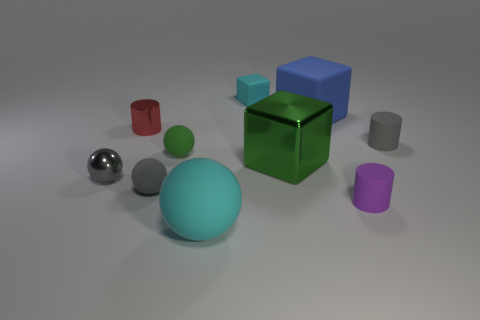The rubber block that is the same size as the green shiny thing is what color?
Your response must be concise. Blue. Are there any small cyan objects of the same shape as the green metal thing?
Provide a short and direct response. Yes. Are there fewer green balls than small green shiny things?
Offer a very short reply. No. There is a big matte ball to the left of the blue object; what is its color?
Offer a terse response. Cyan. There is a cyan rubber object to the left of the tiny rubber thing behind the small metallic cylinder; what is its shape?
Give a very brief answer. Sphere. Is the material of the tiny purple thing the same as the sphere behind the green shiny object?
Provide a short and direct response. Yes. There is a small object that is the same color as the big rubber ball; what is its shape?
Provide a short and direct response. Cube. What number of green metallic blocks are the same size as the gray cylinder?
Provide a succinct answer. 0. Are there fewer red metal cylinders that are behind the tiny cyan cube than blue cylinders?
Provide a succinct answer. No. There is a large matte cube; what number of large metal blocks are behind it?
Provide a short and direct response. 0. 